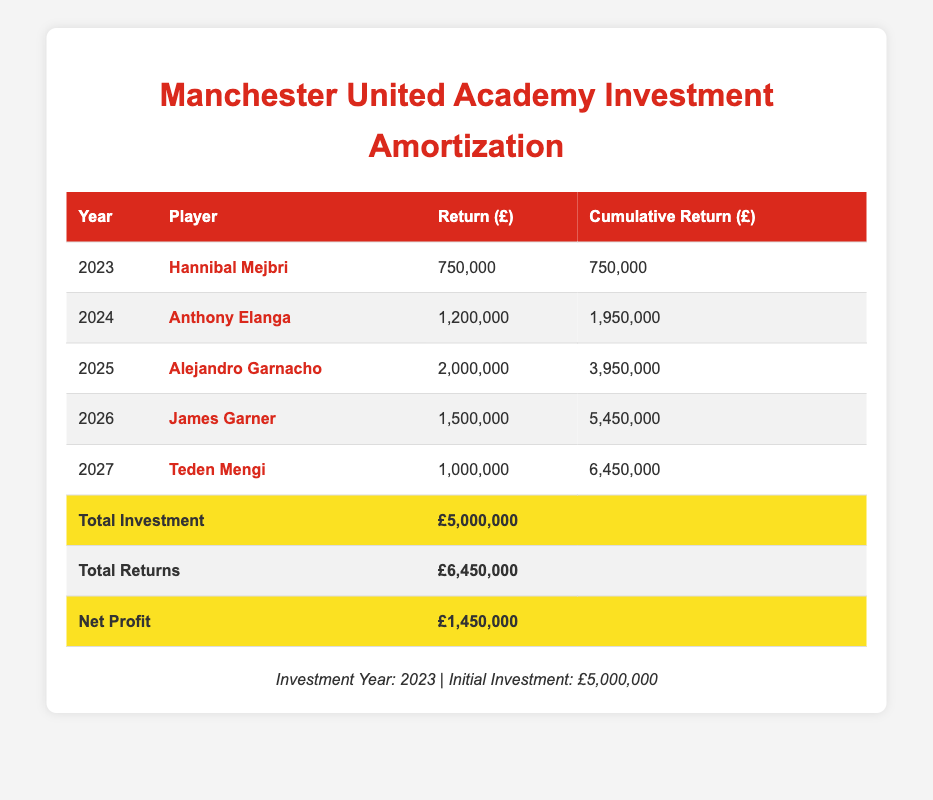What is the total return generated in 2025? In 2025, the return generated is listed as £2,000,000 for Alejandro Garnacho.
Answer: 2,000,000 What is the cumulative return by the year 2026? The cumulative return for 2026 is given as £5,450,000, which is the total return accrued up to that year.
Answer: 5,450,000 Did Teden Mengi generate a return higher than £1,000,000? Teden Mengi's return, as shown in the table, is exactly £1,000,000, which means he did not generate a return higher than that amount.
Answer: No How much profit was made after accounting for the initial investment? Net profit is calculated by subtracting the total investment (£5,000,000) from total returns (£6,450,000), resulting in a net profit of £1,450,000.
Answer: 1,450,000 What is the average annual return over the five years from 2023 to 2027? The total return over these five years is £6,450,000; dividing this by 5 years gives an average annual return of £1,290,000.
Answer: 1,290,000 Which player had the highest return and what was the amount? Alejandro Garnacho had the highest return at £2,000,000, which is noted in the return column for the year 2025.
Answer: Alejandro Garnacho, 2,000,000 What was the cumulative return after the second year, 2024? By 2024, the cumulative return was £1,950,000, which includes the return from Hannibal Mejbri in 2023 and Anthony Elanga in 2024.
Answer: 1,950,000 How much more was returned in 2025 compared to 2024? The return in 2025 was £2,000,000 compared to £1,200,000 in 2024, so the difference is £800,000 (2,000,000 - 1,200,000).
Answer: 800,000 What percentage of the total investment was returned by the end of 2027? The total returns by 2027 (£6,450,000) divided by the total investment (£5,000,000), which equals 129% (6,450,000 / 5,000,000 * 100).
Answer: 129% 